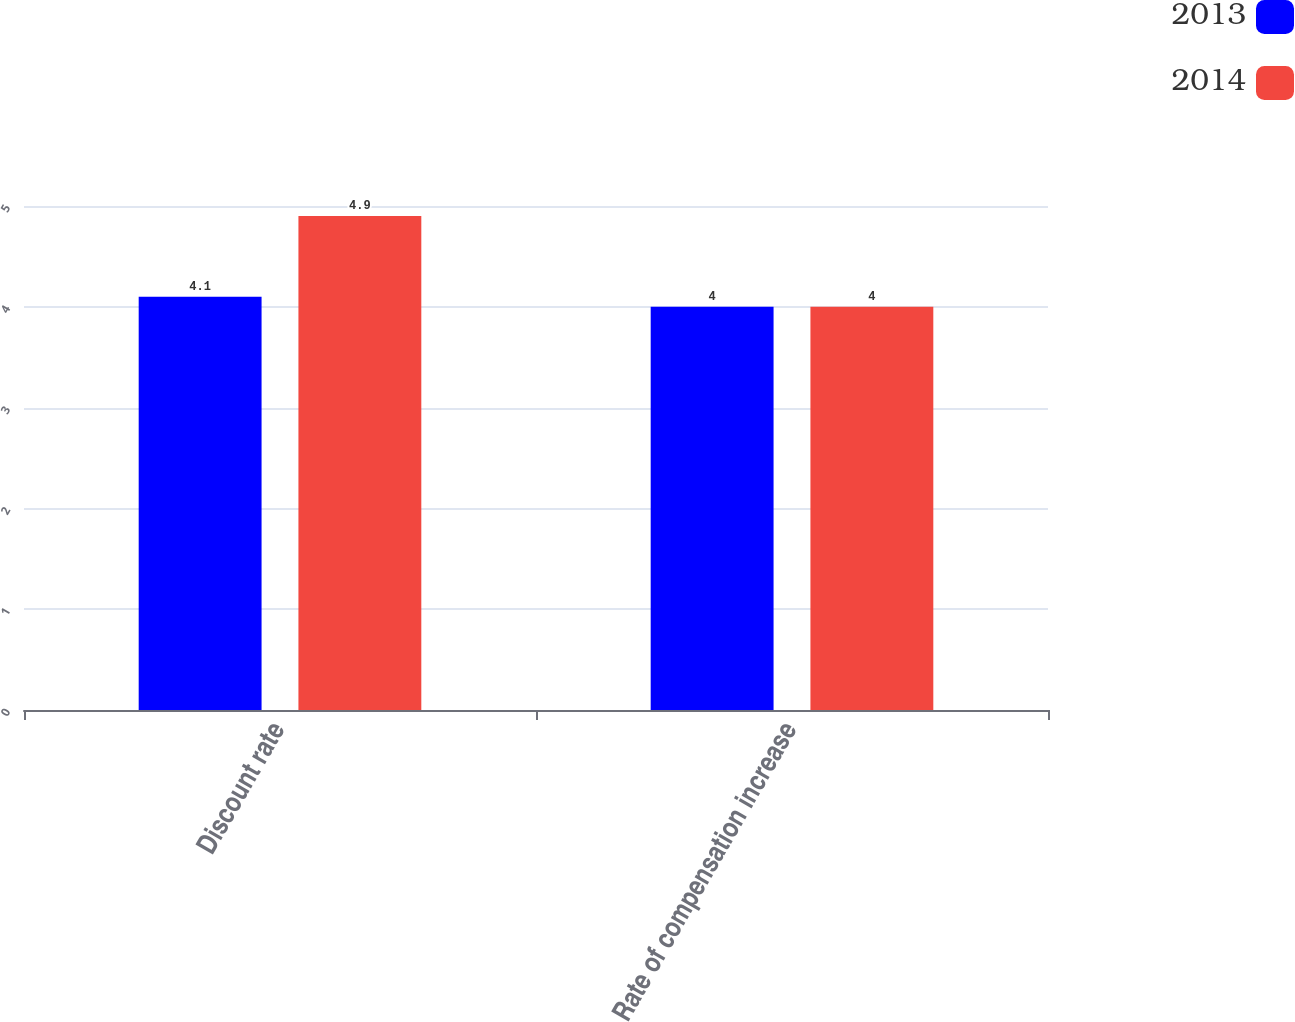<chart> <loc_0><loc_0><loc_500><loc_500><stacked_bar_chart><ecel><fcel>Discount rate<fcel>Rate of compensation increase<nl><fcel>2013<fcel>4.1<fcel>4<nl><fcel>2014<fcel>4.9<fcel>4<nl></chart> 